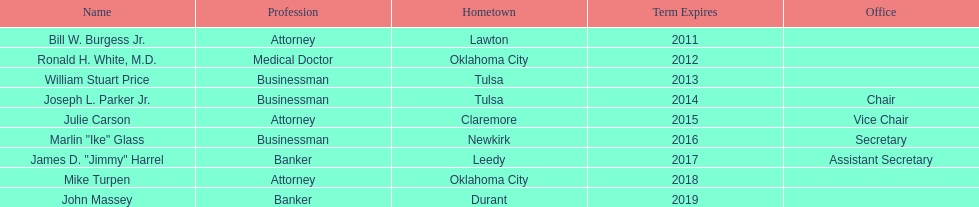How many state regents currently have their office titles listed? 4. 